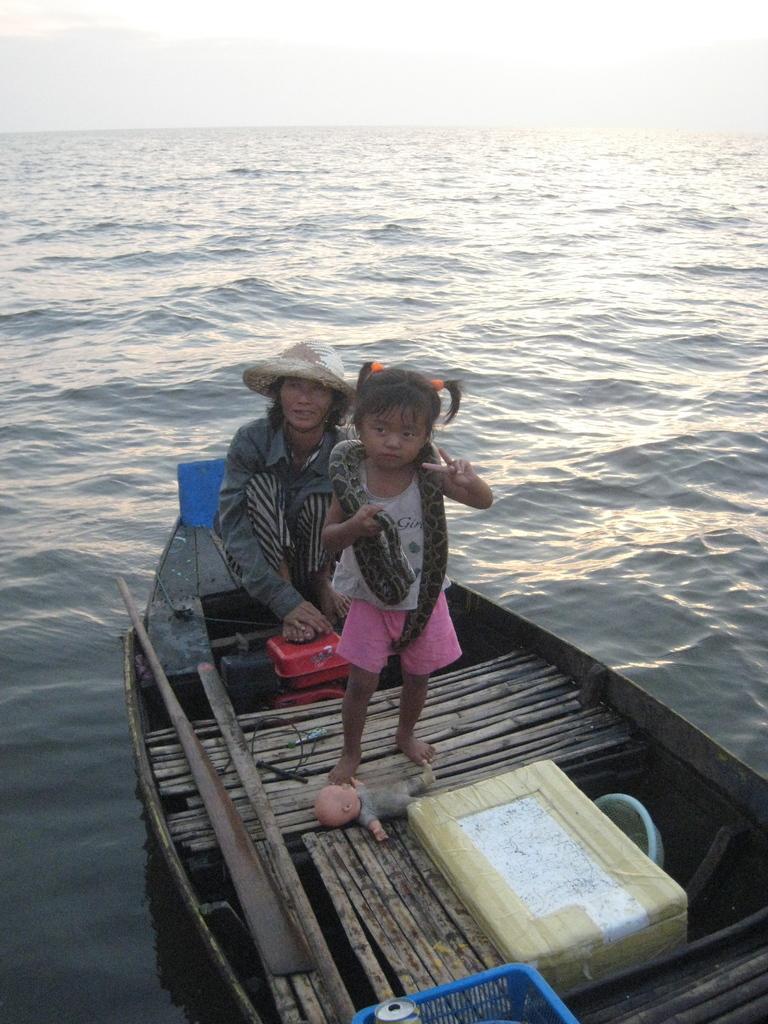Could you give a brief overview of what you see in this image? In this image I can see a woman and a kid in the boat. The kid is holding a snake in her hands. There are few objects in the boat. I can see an ocean. At the top I can see the sky. 